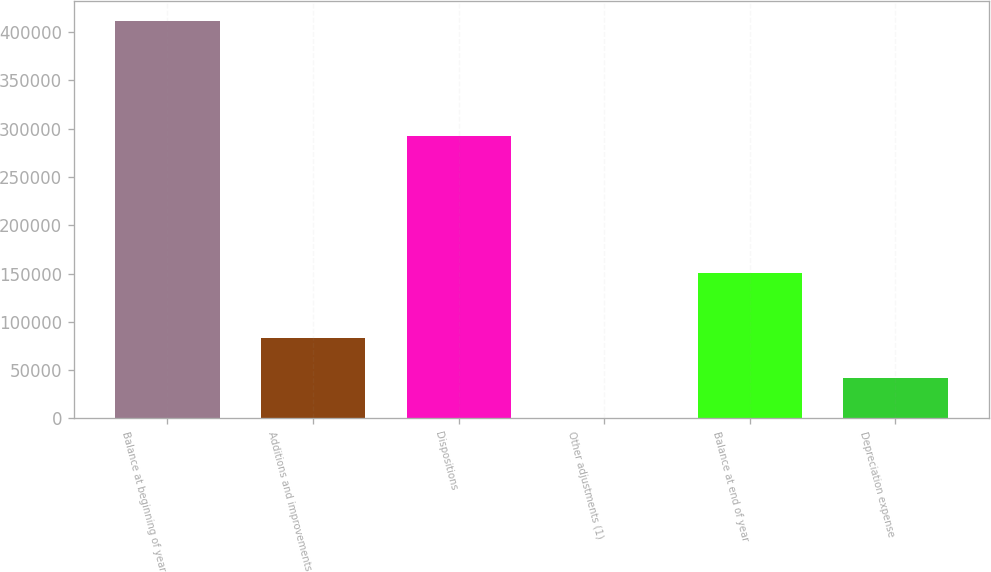Convert chart to OTSL. <chart><loc_0><loc_0><loc_500><loc_500><bar_chart><fcel>Balance at beginning of year<fcel>Additions and improvements<fcel>Dispositions<fcel>Other adjustments (1)<fcel>Balance at end of year<fcel>Depreciation expense<nl><fcel>412061<fcel>82801<fcel>292099<fcel>486<fcel>150511<fcel>41643.5<nl></chart> 